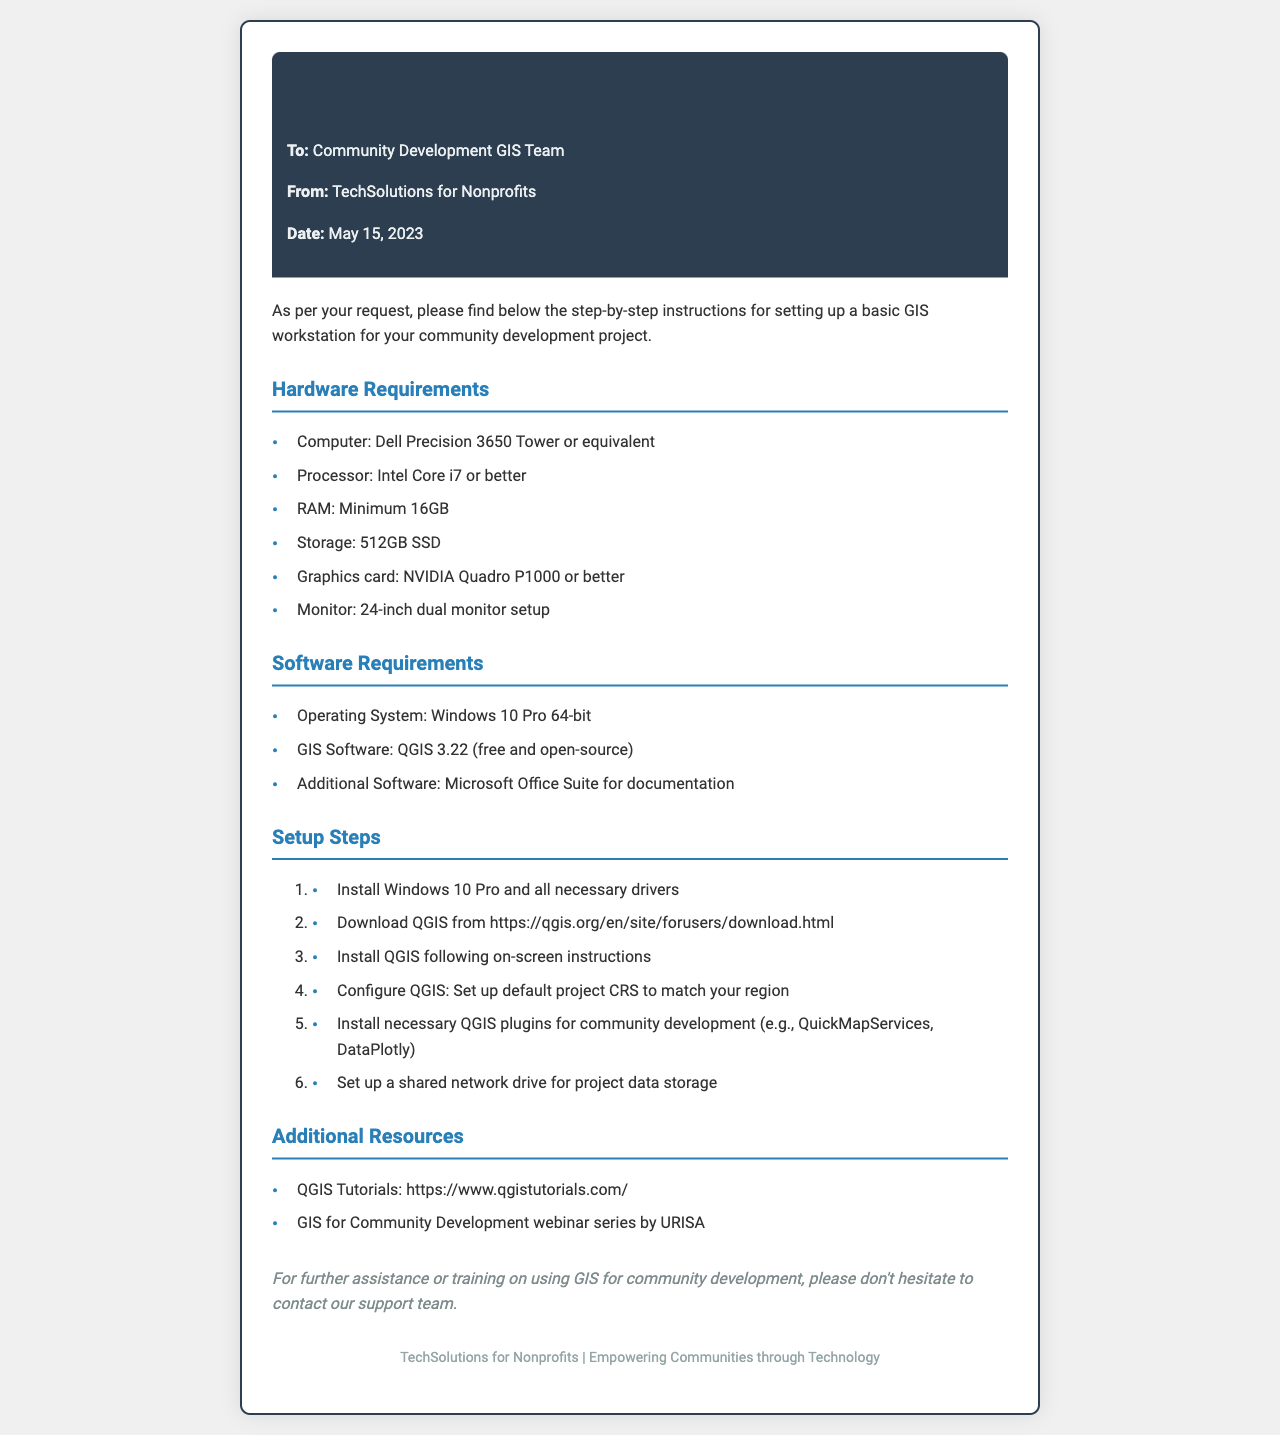what are the hardware requirements? The hardware requirements are specified in a list, including computer type, processor, RAM, storage, graphics card, and monitor setup.
Answer: Computer: Dell Precision 3650 Tower or equivalent what is the minimum RAM required? The document states the minimum RAM requirement in the hardware section, clearly stating the amount needed for the GIS workstation.
Answer: 16GB which software is recommended for GIS? The document mentions the specific GIS software that is to be used, including the version that is appropriate for the workstation setup.
Answer: QGIS 3.22 how many steps are there in the setup process? The setup steps are numbered in an ordered list, providing a clear count of the total steps required for installation.
Answer: 6 what is the purpose of this fax? The introduction clearly states the purpose of the document, which outlines the instructions for setting up a GIS workstation.
Answer: Step-by-step instructions what kind of monitor setup is recommended? The hardware requirements list the specifications for the monitor setup recommended for the GIS workstation.
Answer: 24-inch dual monitor setup which organization sent this document? The fax header includes information about the sender, identifying the organization responsible for providing this information.
Answer: TechSolutions for Nonprofits 